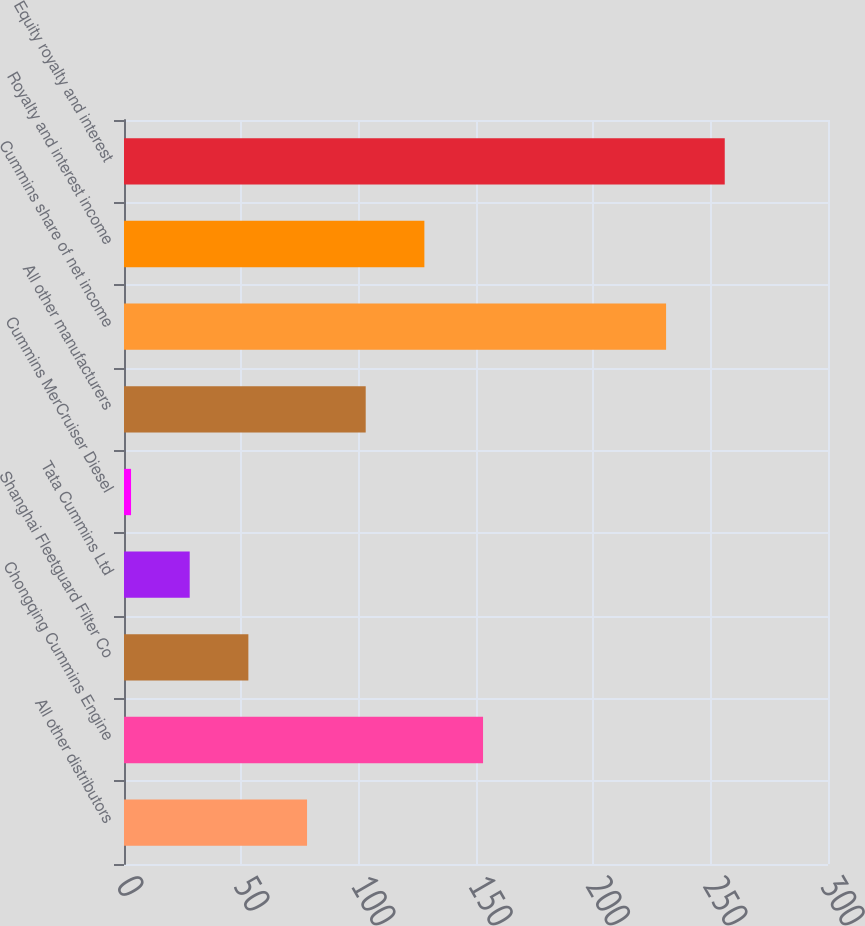<chart> <loc_0><loc_0><loc_500><loc_500><bar_chart><fcel>All other distributors<fcel>Chongqing Cummins Engine<fcel>Shanghai Fleetguard Filter Co<fcel>Tata Cummins Ltd<fcel>Cummins MerCruiser Diesel<fcel>All other manufacturers<fcel>Cummins share of net income<fcel>Royalty and interest income<fcel>Equity royalty and interest<nl><fcel>78<fcel>153<fcel>53<fcel>28<fcel>3<fcel>103<fcel>231<fcel>128<fcel>256<nl></chart> 